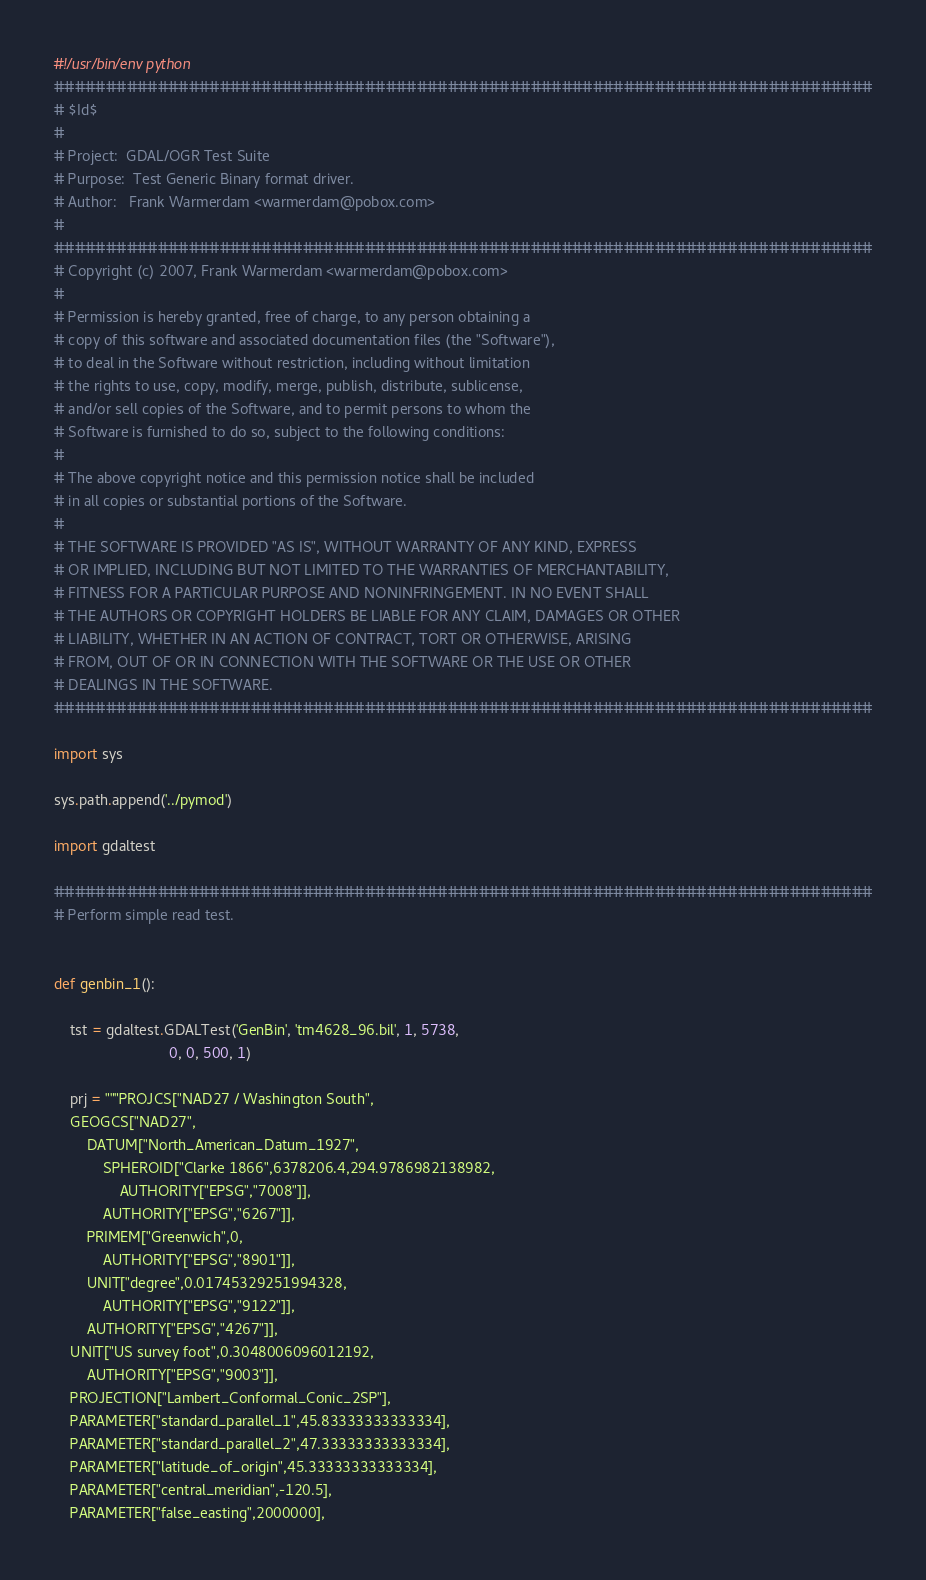Convert code to text. <code><loc_0><loc_0><loc_500><loc_500><_Python_>#!/usr/bin/env python
###############################################################################
# $Id$
#
# Project:  GDAL/OGR Test Suite
# Purpose:  Test Generic Binary format driver.
# Author:   Frank Warmerdam <warmerdam@pobox.com>
#
###############################################################################
# Copyright (c) 2007, Frank Warmerdam <warmerdam@pobox.com>
#
# Permission is hereby granted, free of charge, to any person obtaining a
# copy of this software and associated documentation files (the "Software"),
# to deal in the Software without restriction, including without limitation
# the rights to use, copy, modify, merge, publish, distribute, sublicense,
# and/or sell copies of the Software, and to permit persons to whom the
# Software is furnished to do so, subject to the following conditions:
#
# The above copyright notice and this permission notice shall be included
# in all copies or substantial portions of the Software.
#
# THE SOFTWARE IS PROVIDED "AS IS", WITHOUT WARRANTY OF ANY KIND, EXPRESS
# OR IMPLIED, INCLUDING BUT NOT LIMITED TO THE WARRANTIES OF MERCHANTABILITY,
# FITNESS FOR A PARTICULAR PURPOSE AND NONINFRINGEMENT. IN NO EVENT SHALL
# THE AUTHORS OR COPYRIGHT HOLDERS BE LIABLE FOR ANY CLAIM, DAMAGES OR OTHER
# LIABILITY, WHETHER IN AN ACTION OF CONTRACT, TORT OR OTHERWISE, ARISING
# FROM, OUT OF OR IN CONNECTION WITH THE SOFTWARE OR THE USE OR OTHER
# DEALINGS IN THE SOFTWARE.
###############################################################################

import sys

sys.path.append('../pymod')

import gdaltest

###############################################################################
# Perform simple read test.


def genbin_1():

    tst = gdaltest.GDALTest('GenBin', 'tm4628_96.bil', 1, 5738,
                            0, 0, 500, 1)

    prj = """PROJCS["NAD27 / Washington South",
    GEOGCS["NAD27",
        DATUM["North_American_Datum_1927",
            SPHEROID["Clarke 1866",6378206.4,294.9786982138982,
                AUTHORITY["EPSG","7008"]],
            AUTHORITY["EPSG","6267"]],
        PRIMEM["Greenwich",0,
            AUTHORITY["EPSG","8901"]],
        UNIT["degree",0.01745329251994328,
            AUTHORITY["EPSG","9122"]],
        AUTHORITY["EPSG","4267"]],
    UNIT["US survey foot",0.3048006096012192,
        AUTHORITY["EPSG","9003"]],
    PROJECTION["Lambert_Conformal_Conic_2SP"],
    PARAMETER["standard_parallel_1",45.83333333333334],
    PARAMETER["standard_parallel_2",47.33333333333334],
    PARAMETER["latitude_of_origin",45.33333333333334],
    PARAMETER["central_meridian",-120.5],
    PARAMETER["false_easting",2000000],</code> 